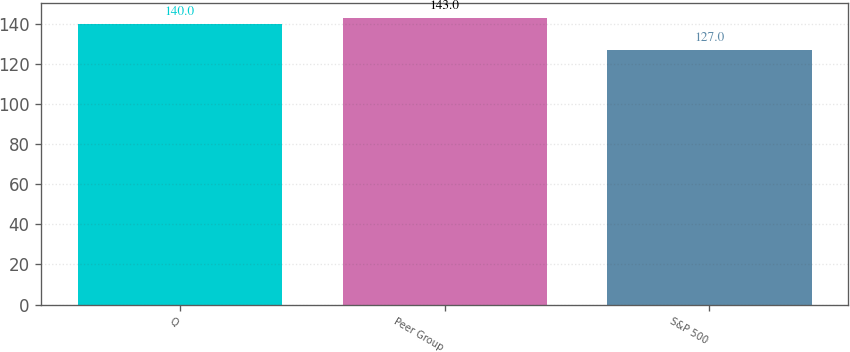<chart> <loc_0><loc_0><loc_500><loc_500><bar_chart><fcel>Q<fcel>Peer Group<fcel>S&P 500<nl><fcel>140<fcel>143<fcel>127<nl></chart> 